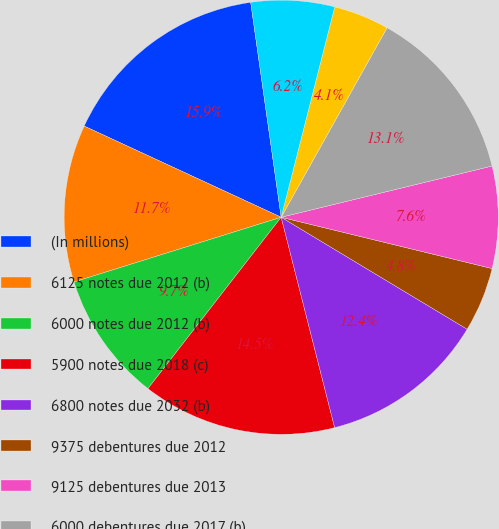Convert chart to OTSL. <chart><loc_0><loc_0><loc_500><loc_500><pie_chart><fcel>(In millions)<fcel>6125 notes due 2012 (b)<fcel>6000 notes due 2012 (b)<fcel>5900 notes due 2018 (c)<fcel>6800 notes due 2032 (b)<fcel>9375 debentures due 2012<fcel>9125 debentures due 2013<fcel>6000 debentures due 2017 (b)<fcel>9375 debentures due 2022<fcel>8500 debentures due 2023<nl><fcel>15.86%<fcel>11.72%<fcel>9.66%<fcel>14.48%<fcel>12.41%<fcel>4.83%<fcel>7.59%<fcel>13.1%<fcel>4.14%<fcel>6.21%<nl></chart> 